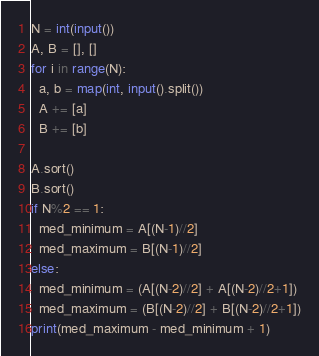<code> <loc_0><loc_0><loc_500><loc_500><_Python_>N = int(input())
A, B = [], []
for i in range(N):
  a, b = map(int, input().split())
  A += [a]
  B += [b]

A.sort()
B.sort()
if N%2 == 1:
  med_minimum = A[(N-1)//2]
  med_maximum = B[(N-1)//2]
else:
  med_minimum = (A[(N-2)//2] + A[(N-2)//2+1])
  med_maximum = (B[(N-2)//2] + B[(N-2)//2+1])
print(med_maximum - med_minimum + 1)
</code> 